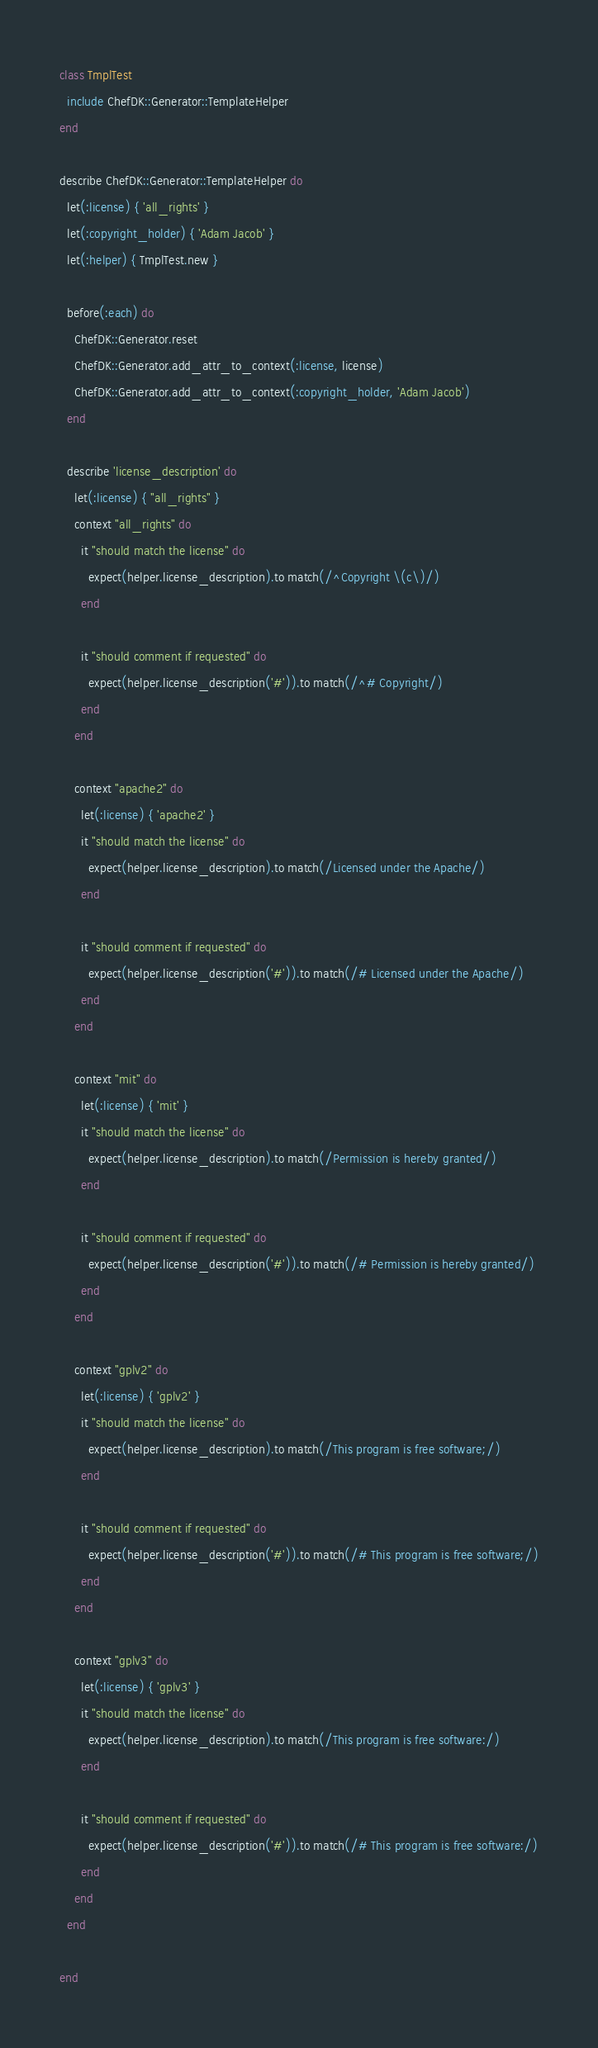Convert code to text. <code><loc_0><loc_0><loc_500><loc_500><_Ruby_>class TmplTest
  include ChefDK::Generator::TemplateHelper
end

describe ChefDK::Generator::TemplateHelper do
  let(:license) { 'all_rights' }
  let(:copyright_holder) { 'Adam Jacob' }
  let(:helper) { TmplTest.new }

  before(:each) do
    ChefDK::Generator.reset
    ChefDK::Generator.add_attr_to_context(:license, license)
    ChefDK::Generator.add_attr_to_context(:copyright_holder, 'Adam Jacob')
  end

  describe 'license_description' do
    let(:license) { "all_rights" }
    context "all_rights" do
      it "should match the license" do
        expect(helper.license_description).to match(/^Copyright \(c\)/)
      end

      it "should comment if requested" do
        expect(helper.license_description('#')).to match(/^# Copyright/)
      end
    end

    context "apache2" do
      let(:license) { 'apache2' }
      it "should match the license" do
        expect(helper.license_description).to match(/Licensed under the Apache/)
      end

      it "should comment if requested" do
        expect(helper.license_description('#')).to match(/# Licensed under the Apache/)
      end
    end

    context "mit" do
      let(:license) { 'mit' }
      it "should match the license" do
        expect(helper.license_description).to match(/Permission is hereby granted/)
      end

      it "should comment if requested" do
        expect(helper.license_description('#')).to match(/# Permission is hereby granted/)
      end
    end

    context "gplv2" do
      let(:license) { 'gplv2' }
      it "should match the license" do
        expect(helper.license_description).to match(/This program is free software;/)
      end

      it "should comment if requested" do
        expect(helper.license_description('#')).to match(/# This program is free software;/)
      end
    end

    context "gplv3" do
      let(:license) { 'gplv3' }
      it "should match the license" do
        expect(helper.license_description).to match(/This program is free software:/)
      end

      it "should comment if requested" do
        expect(helper.license_description('#')).to match(/# This program is free software:/)
      end
    end
  end

end

</code> 